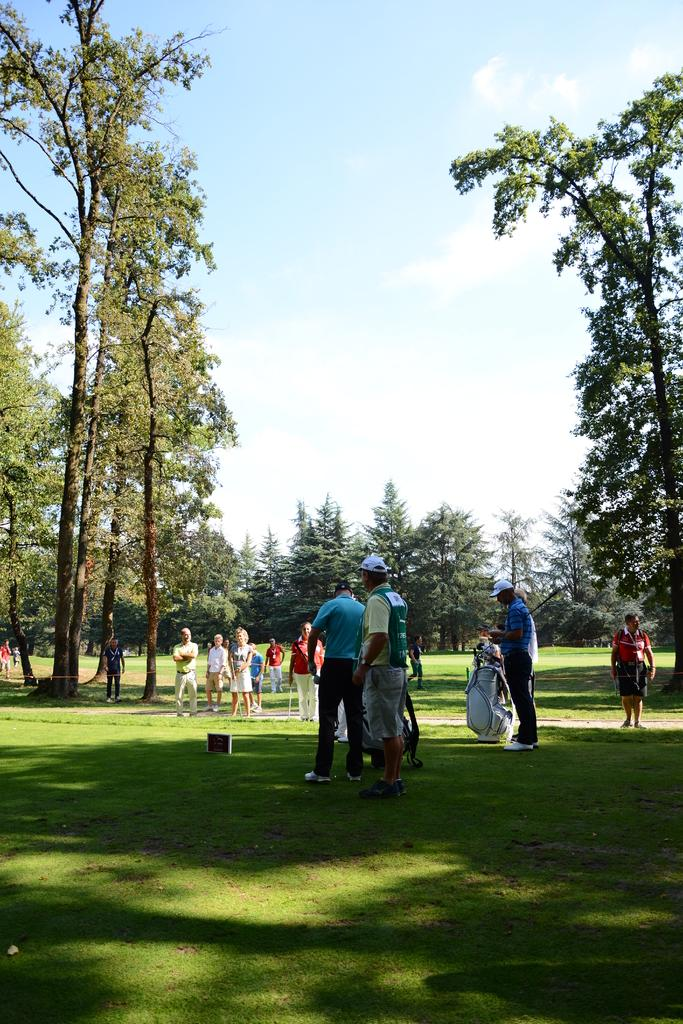Who or what can be seen in the image? There are people in the image. What is on the grass in the image? There is a board on the grass. What can be seen in the background of the image? There are trees, grass, and the sky visible in the background of the image. What is the condition of the sky in the image? Clouds are present in the sky. What type of test is being conducted on the tramp in the image? There is no tramp or test present in the image. 